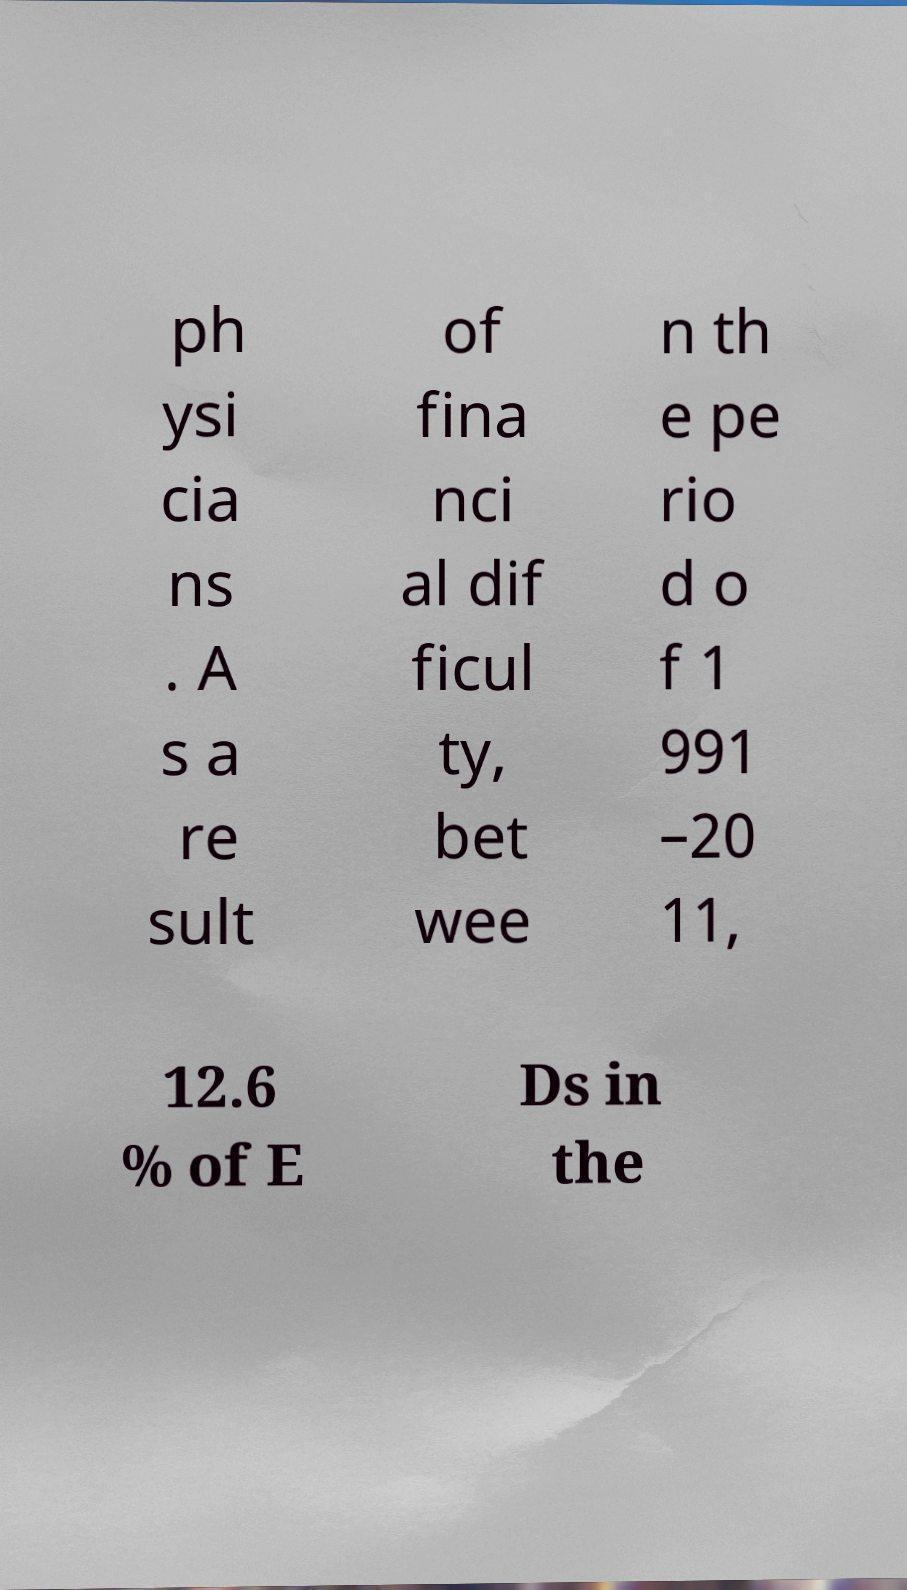There's text embedded in this image that I need extracted. Can you transcribe it verbatim? ph ysi cia ns . A s a re sult of fina nci al dif ficul ty, bet wee n th e pe rio d o f 1 991 –20 11, 12.6 % of E Ds in the 